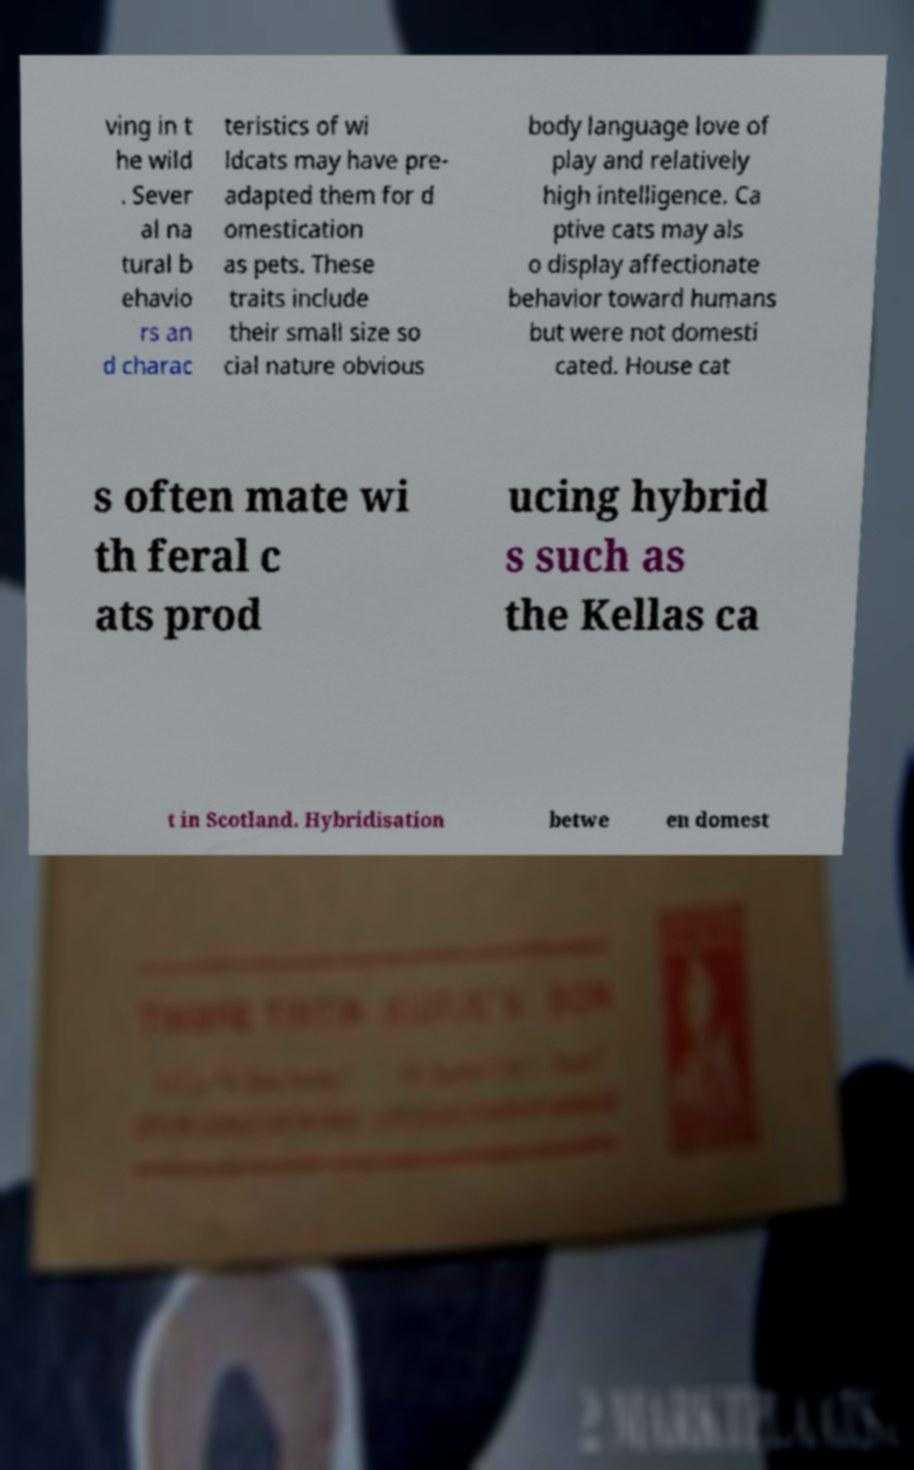Could you extract and type out the text from this image? ving in t he wild . Sever al na tural b ehavio rs an d charac teristics of wi ldcats may have pre- adapted them for d omestication as pets. These traits include their small size so cial nature obvious body language love of play and relatively high intelligence. Ca ptive cats may als o display affectionate behavior toward humans but were not domesti cated. House cat s often mate wi th feral c ats prod ucing hybrid s such as the Kellas ca t in Scotland. Hybridisation betwe en domest 